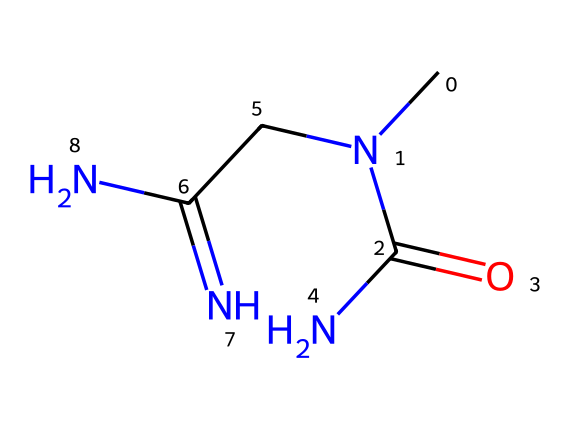What is the molecular formula of creatine? The SMILES representation can be translated to the molecular formula by identifying the atoms present. Reading the SMILES, we find 4 carbon atoms, 9 hydrogen atoms, 3 nitrogen atoms, and 1 oxygen atom, leading to the formula C4H9N3O.
Answer: C4H9N3O How many nitrogen atoms are in creatine? By examining the SMILES notation, we can see that there are three distinct nitrogen atoms indicated by the "N" symbols in the structure.
Answer: 3 What type of functional group is present in creatine? The SMILES notation indicates the presence of a carbonyl group (C=O) found in the amide portion of the structure, which is a defining feature of creatine, pointing to its classification as an amide.
Answer: amide What effect does creatine have on muscle performance? Creatine plays a crucial role in ATP regeneration during high-intensity exercise, which improves performance and enhances muscle mass due to its ability to increase the availability of energy during short bursts of activity.
Answer: improves performance How many double bonds are present in creatine? By analyzing the SMILES representation, we notice that there is one double bond between a carbon and an oxygen (C=O) but no other carbon-carbon double bonds. Therefore, the total is one double bond.
Answer: 1 What is the overall charge of creatine? The SMILES representation shows no explicit indication of a charge, and generally, creatine is neutral in its standard form, hence it can be concluded that the overall charge is zero.
Answer: 0 